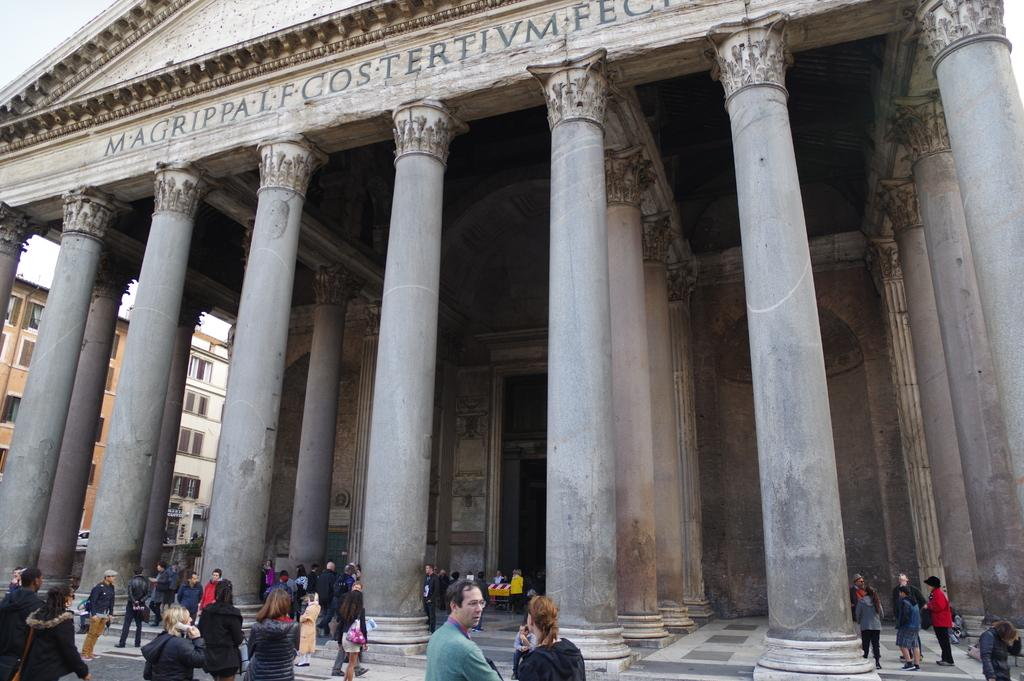What type of structures are visible in the image? There are buildings in the image. What architectural features can be seen on the buildings? There are windows and pillars visible on the buildings. Are there any people present in the image? Yes, there are people in the image. How can you describe the appearance of the people in the image? The people are wearing different color dresses. What emotion are the people expressing in the image? The image does not show any specific emotions or expressions on the people's faces, so it cannot be determined from the image. 